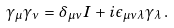<formula> <loc_0><loc_0><loc_500><loc_500>\gamma _ { \mu } \gamma _ { \nu } \, = \, \delta _ { \mu \nu } I \, + \, i \epsilon _ { \mu \nu \lambda } \gamma _ { \lambda } \, .</formula> 